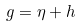<formula> <loc_0><loc_0><loc_500><loc_500>g = \eta + h</formula> 